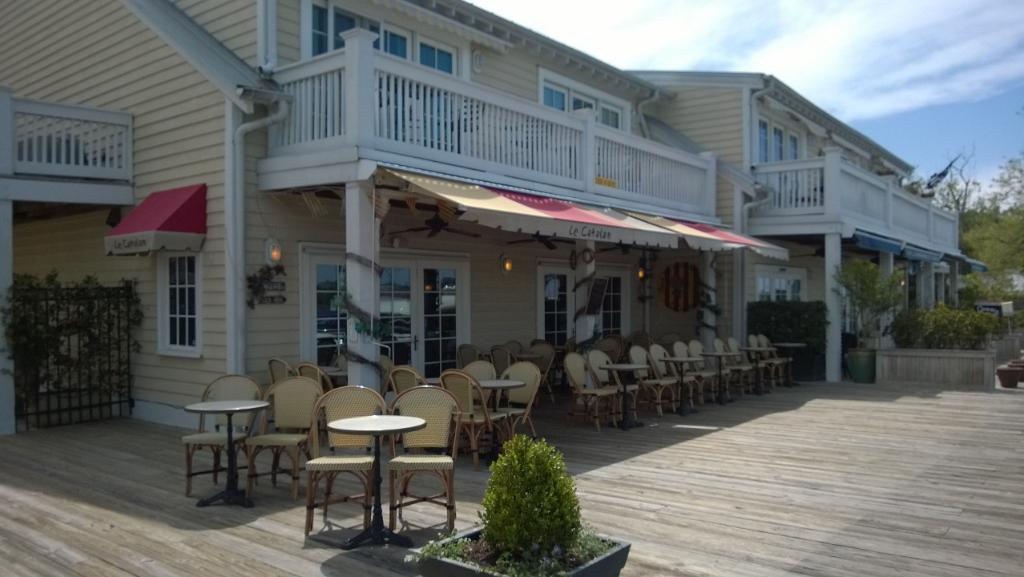What type of structures can be seen in the image? There are houses in the image. What type of furniture is visible in the image? There are chairs and tables in the image. What type of vegetation is present in the image? There are trees and potted plants in the image. Is there a fictional character exchanging secrets with a crook in the image? There is no fictional character or crook present in the image. 